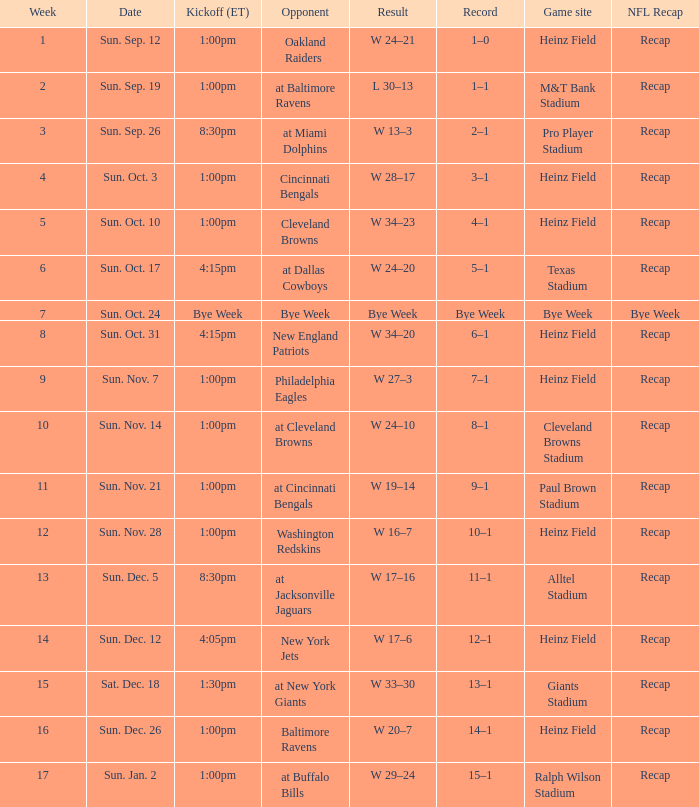Which Game site has a Kickoff (ET) of 1:00pm, and a Record of 4–1? Heinz Field. 